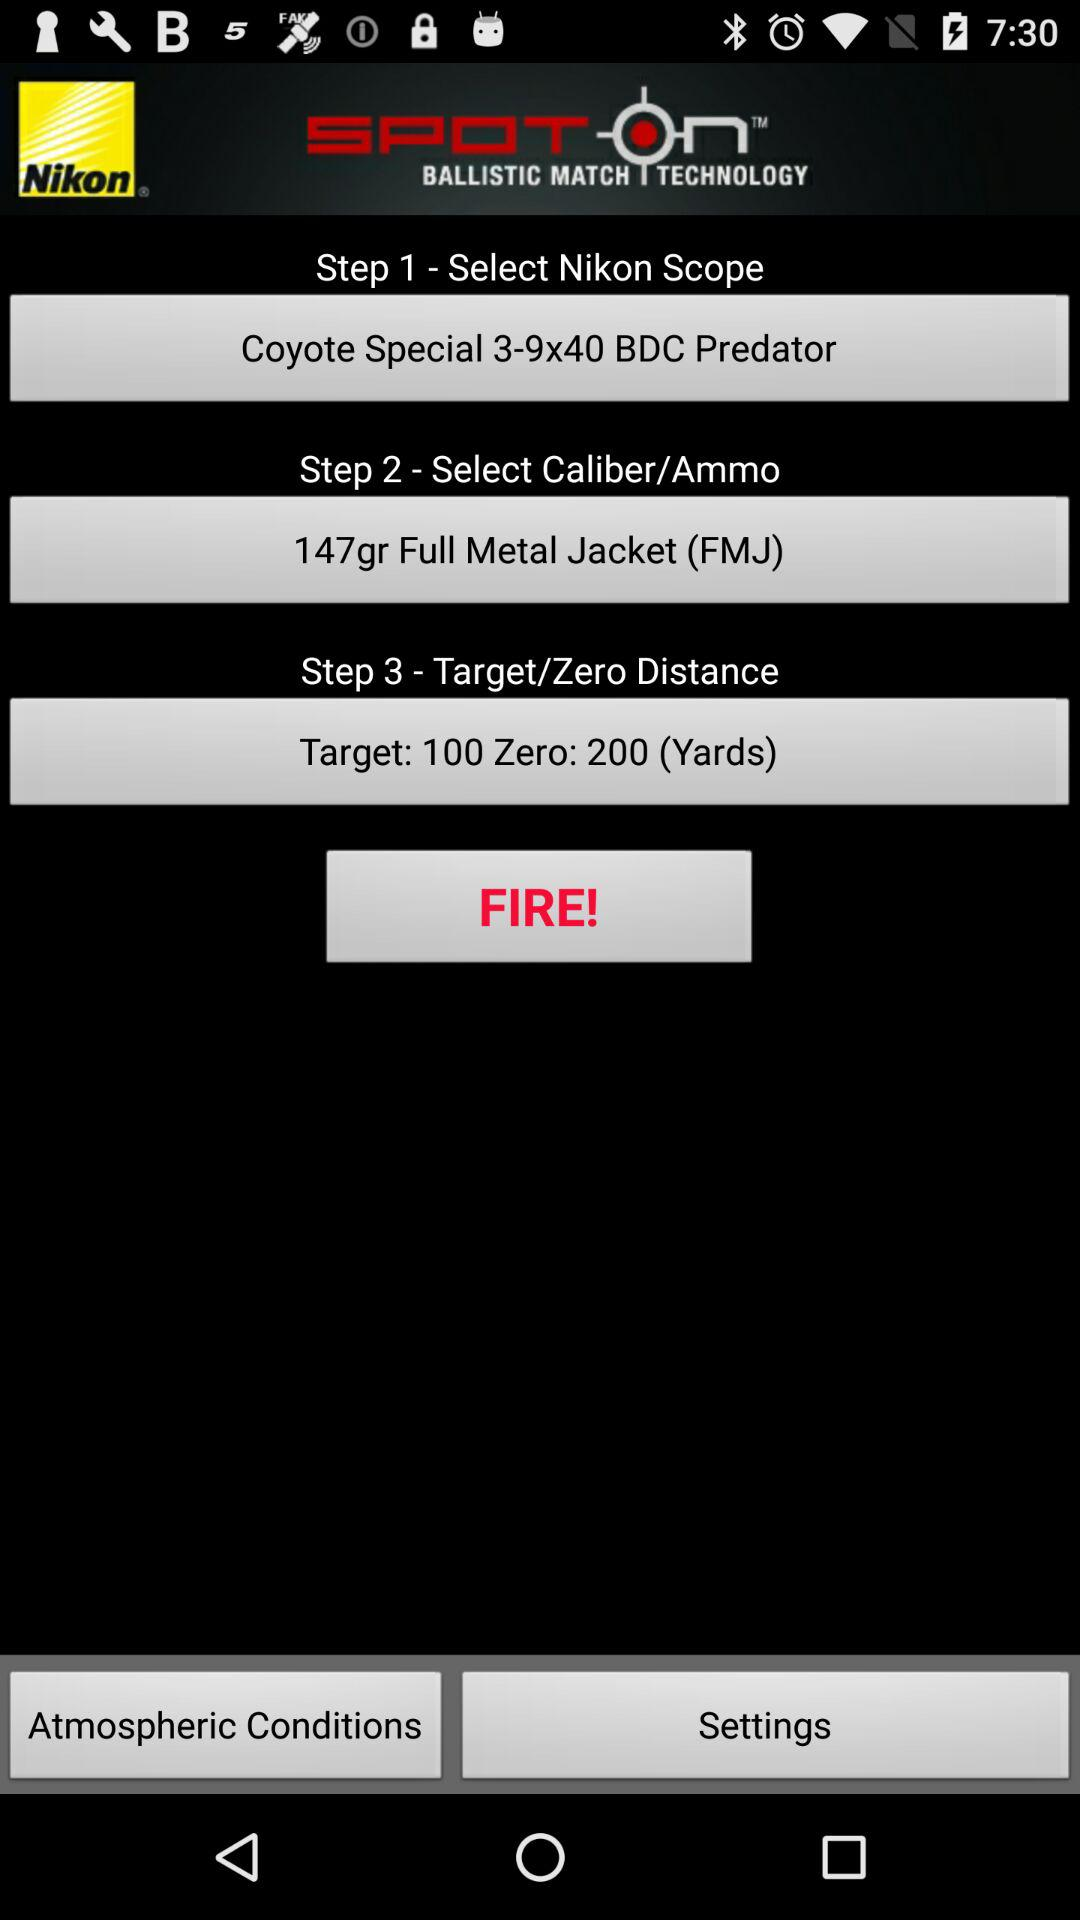How many steps are there in the process?
Answer the question using a single word or phrase. 3 